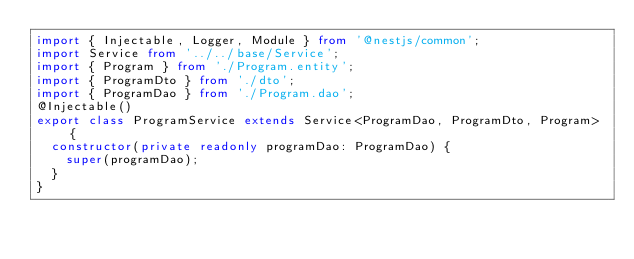<code> <loc_0><loc_0><loc_500><loc_500><_TypeScript_>import { Injectable, Logger, Module } from '@nestjs/common';
import Service from '../../base/Service';
import { Program } from './Program.entity';
import { ProgramDto } from './dto';
import { ProgramDao } from './Program.dao';
@Injectable()
export class ProgramService extends Service<ProgramDao, ProgramDto, Program> {
  constructor(private readonly programDao: ProgramDao) {
    super(programDao);
  }
}
</code> 